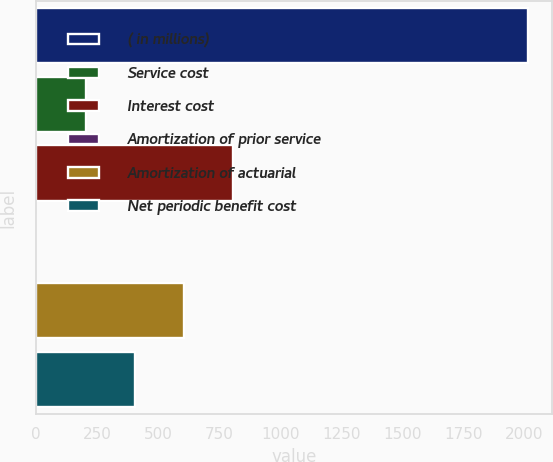<chart> <loc_0><loc_0><loc_500><loc_500><bar_chart><fcel>( in millions)<fcel>Service cost<fcel>Interest cost<fcel>Amortization of prior service<fcel>Amortization of actuarial<fcel>Net periodic benefit cost<nl><fcel>2014<fcel>203.2<fcel>806.8<fcel>2<fcel>605.6<fcel>404.4<nl></chart> 